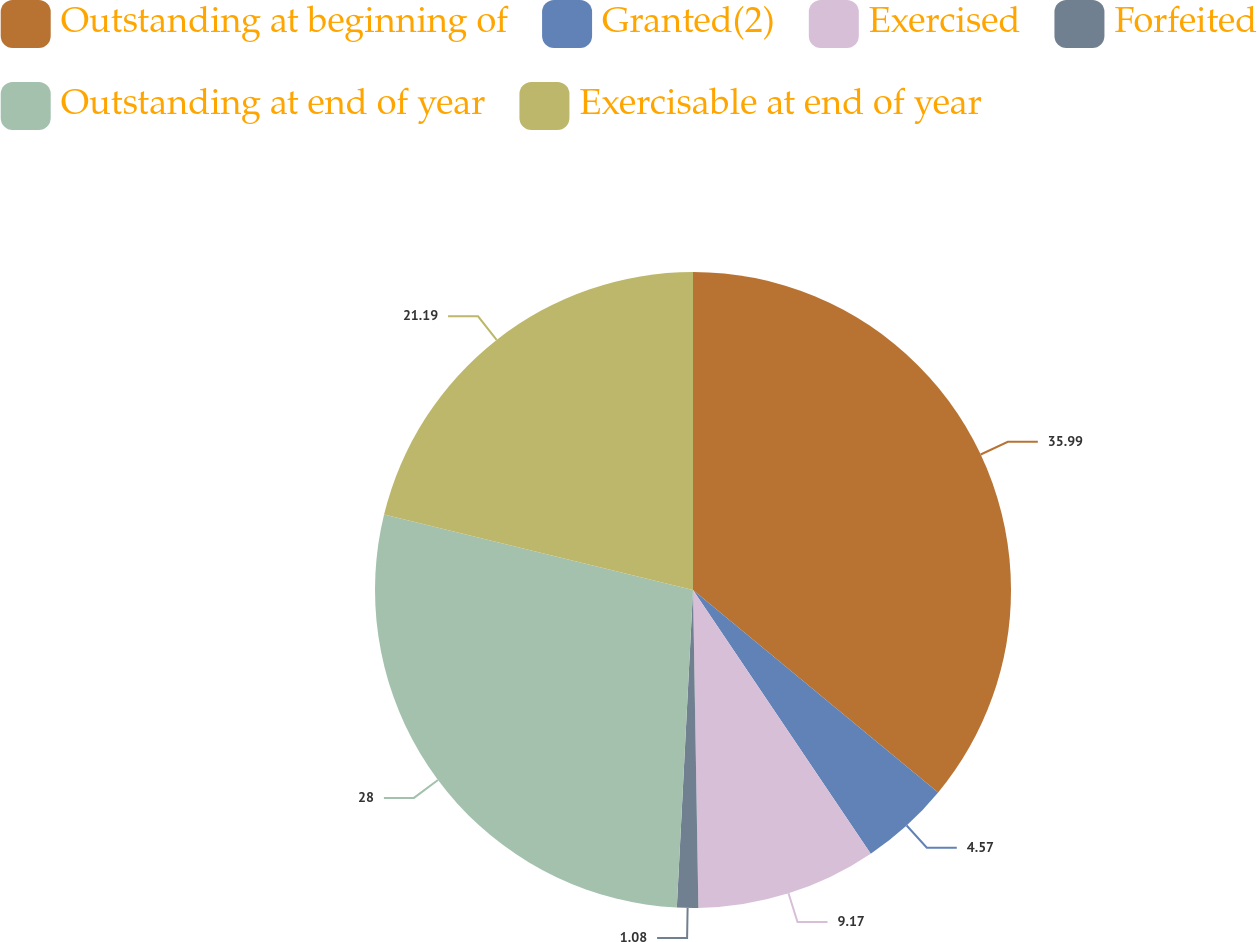Convert chart to OTSL. <chart><loc_0><loc_0><loc_500><loc_500><pie_chart><fcel>Outstanding at beginning of<fcel>Granted(2)<fcel>Exercised<fcel>Forfeited<fcel>Outstanding at end of year<fcel>Exercisable at end of year<nl><fcel>35.99%<fcel>4.57%<fcel>9.17%<fcel>1.08%<fcel>28.0%<fcel>21.19%<nl></chart> 